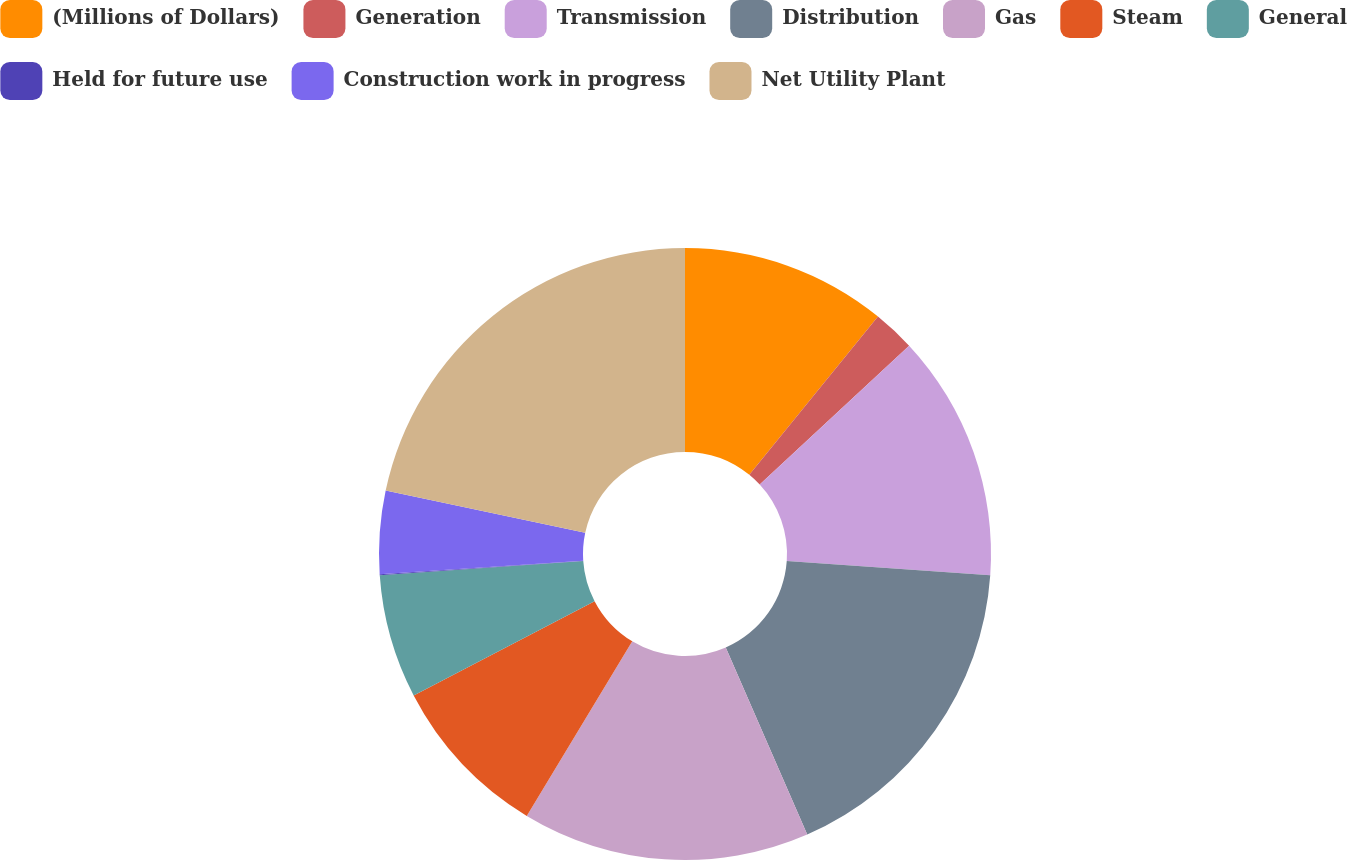Convert chart. <chart><loc_0><loc_0><loc_500><loc_500><pie_chart><fcel>(Millions of Dollars)<fcel>Generation<fcel>Transmission<fcel>Distribution<fcel>Gas<fcel>Steam<fcel>General<fcel>Held for future use<fcel>Construction work in progress<fcel>Net Utility Plant<nl><fcel>10.86%<fcel>2.22%<fcel>13.03%<fcel>17.35%<fcel>15.19%<fcel>8.7%<fcel>6.54%<fcel>0.06%<fcel>4.38%<fcel>21.67%<nl></chart> 